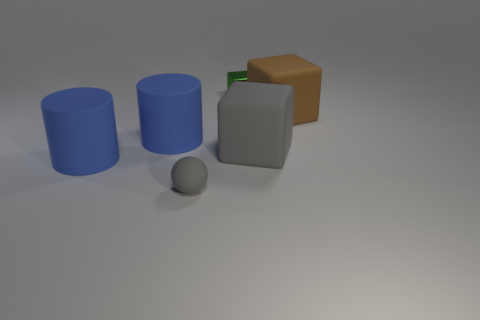Is there anything else that has the same material as the green thing?
Give a very brief answer. No. What number of objects are in front of the big brown thing and right of the gray matte ball?
Offer a very short reply. 1. Is the number of large brown rubber things on the left side of the sphere less than the number of large cylinders that are to the left of the green metal thing?
Keep it short and to the point. Yes. Is the big brown thing the same shape as the tiny metallic object?
Give a very brief answer. Yes. How many other things are the same size as the green shiny block?
Provide a short and direct response. 1. What number of things are tiny things that are in front of the metal block or gray things that are on the left side of the small block?
Offer a terse response. 1. How many gray things have the same shape as the big brown thing?
Offer a terse response. 1. What is the thing that is on the left side of the big gray matte object and to the right of the tiny gray rubber object made of?
Your answer should be compact. Metal. What number of small blocks are to the right of the small green metal block?
Provide a succinct answer. 0. How many large rubber cubes are there?
Your response must be concise. 2. 